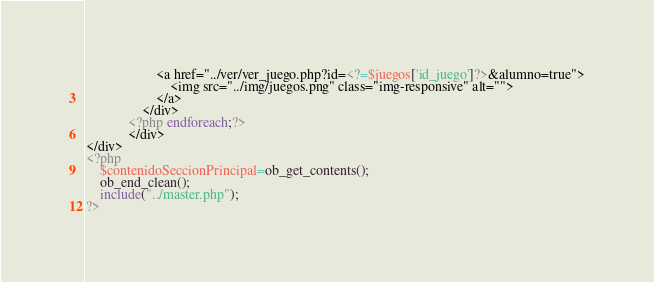Convert code to text. <code><loc_0><loc_0><loc_500><loc_500><_PHP_>                    <a href="../ver/ver_juego.php?id=<?=$juegos['id_juego']?>&alumno=true">
                        <img src="../img/juegos.png" class="img-responsive" alt="">
                    </a>
                </div>
            <?php endforeach;?>
            </div>
</div>
<?php
	$contenidoSeccionPrincipal=ob_get_contents();
	ob_end_clean();
	include("../master.php");
?></code> 